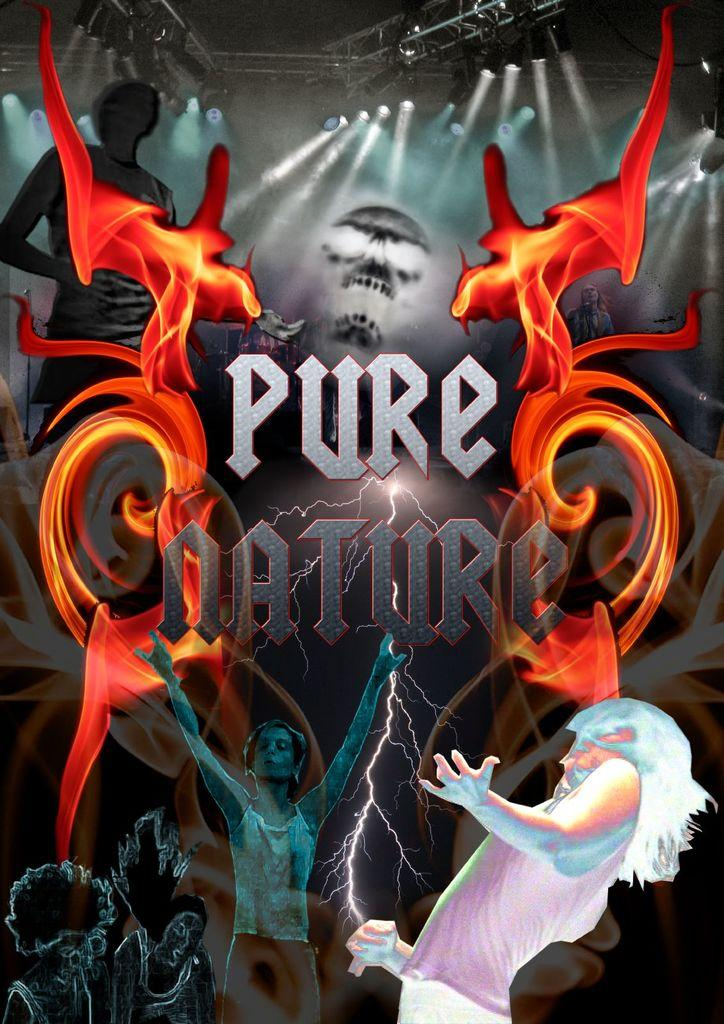What type of visual representation is shown in the image? The image is a poster. What is featured on the poster? There are people, text, fire, lights, rods, and objects depicted in the poster. Can you describe the background of the poster? The background of the poster is dark. What type of legal advice can be obtained from the fireman depicted in the poster? There is no fireman depicted in the poster; it features people, text, fire, lights, rods, and objects. What type of thing is the poster made of? The poster is a printed visual representation, typically made of paper or other durable materials. 